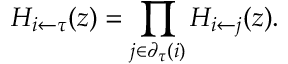Convert formula to latex. <formula><loc_0><loc_0><loc_500><loc_500>H _ { i \leftarrow \tau } ( z ) = \prod _ { j \in \partial _ { \tau } ( i ) } H _ { i \leftarrow j } ( z ) .</formula> 